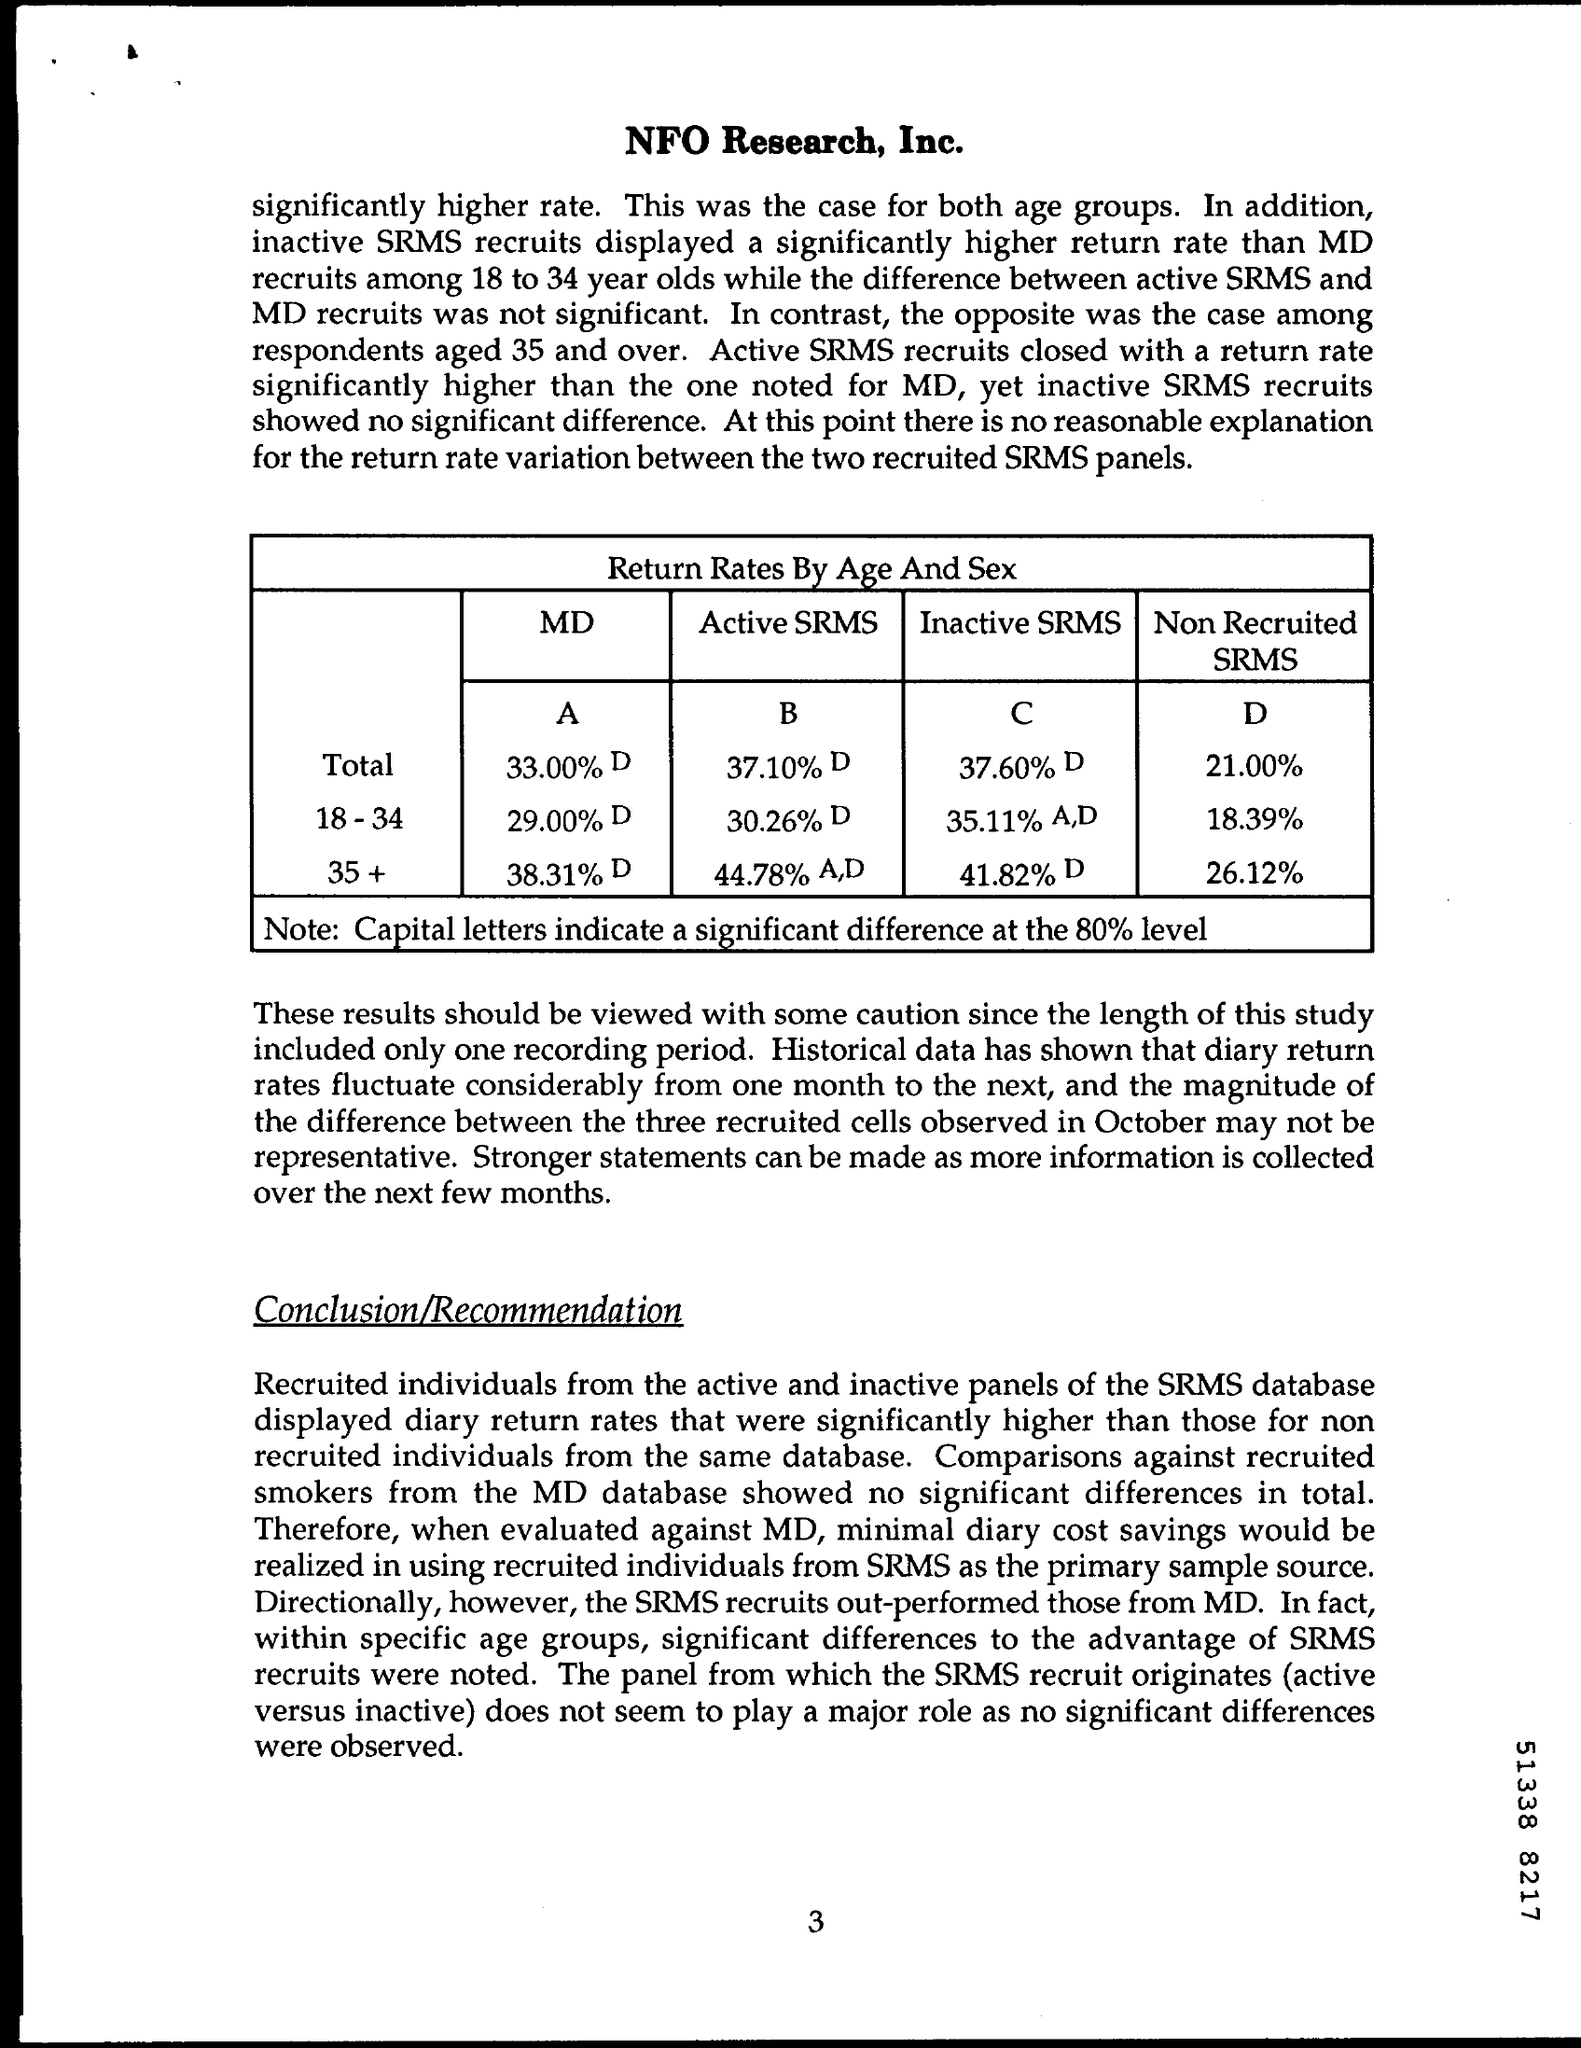Identify some key points in this picture. The title of the table is "return rates by age and sex. The page number on this document is 3. The non-recruited SRMS of ages 18-34 is 18.39%. NFO Research, Inc. is written at the top of the page. 